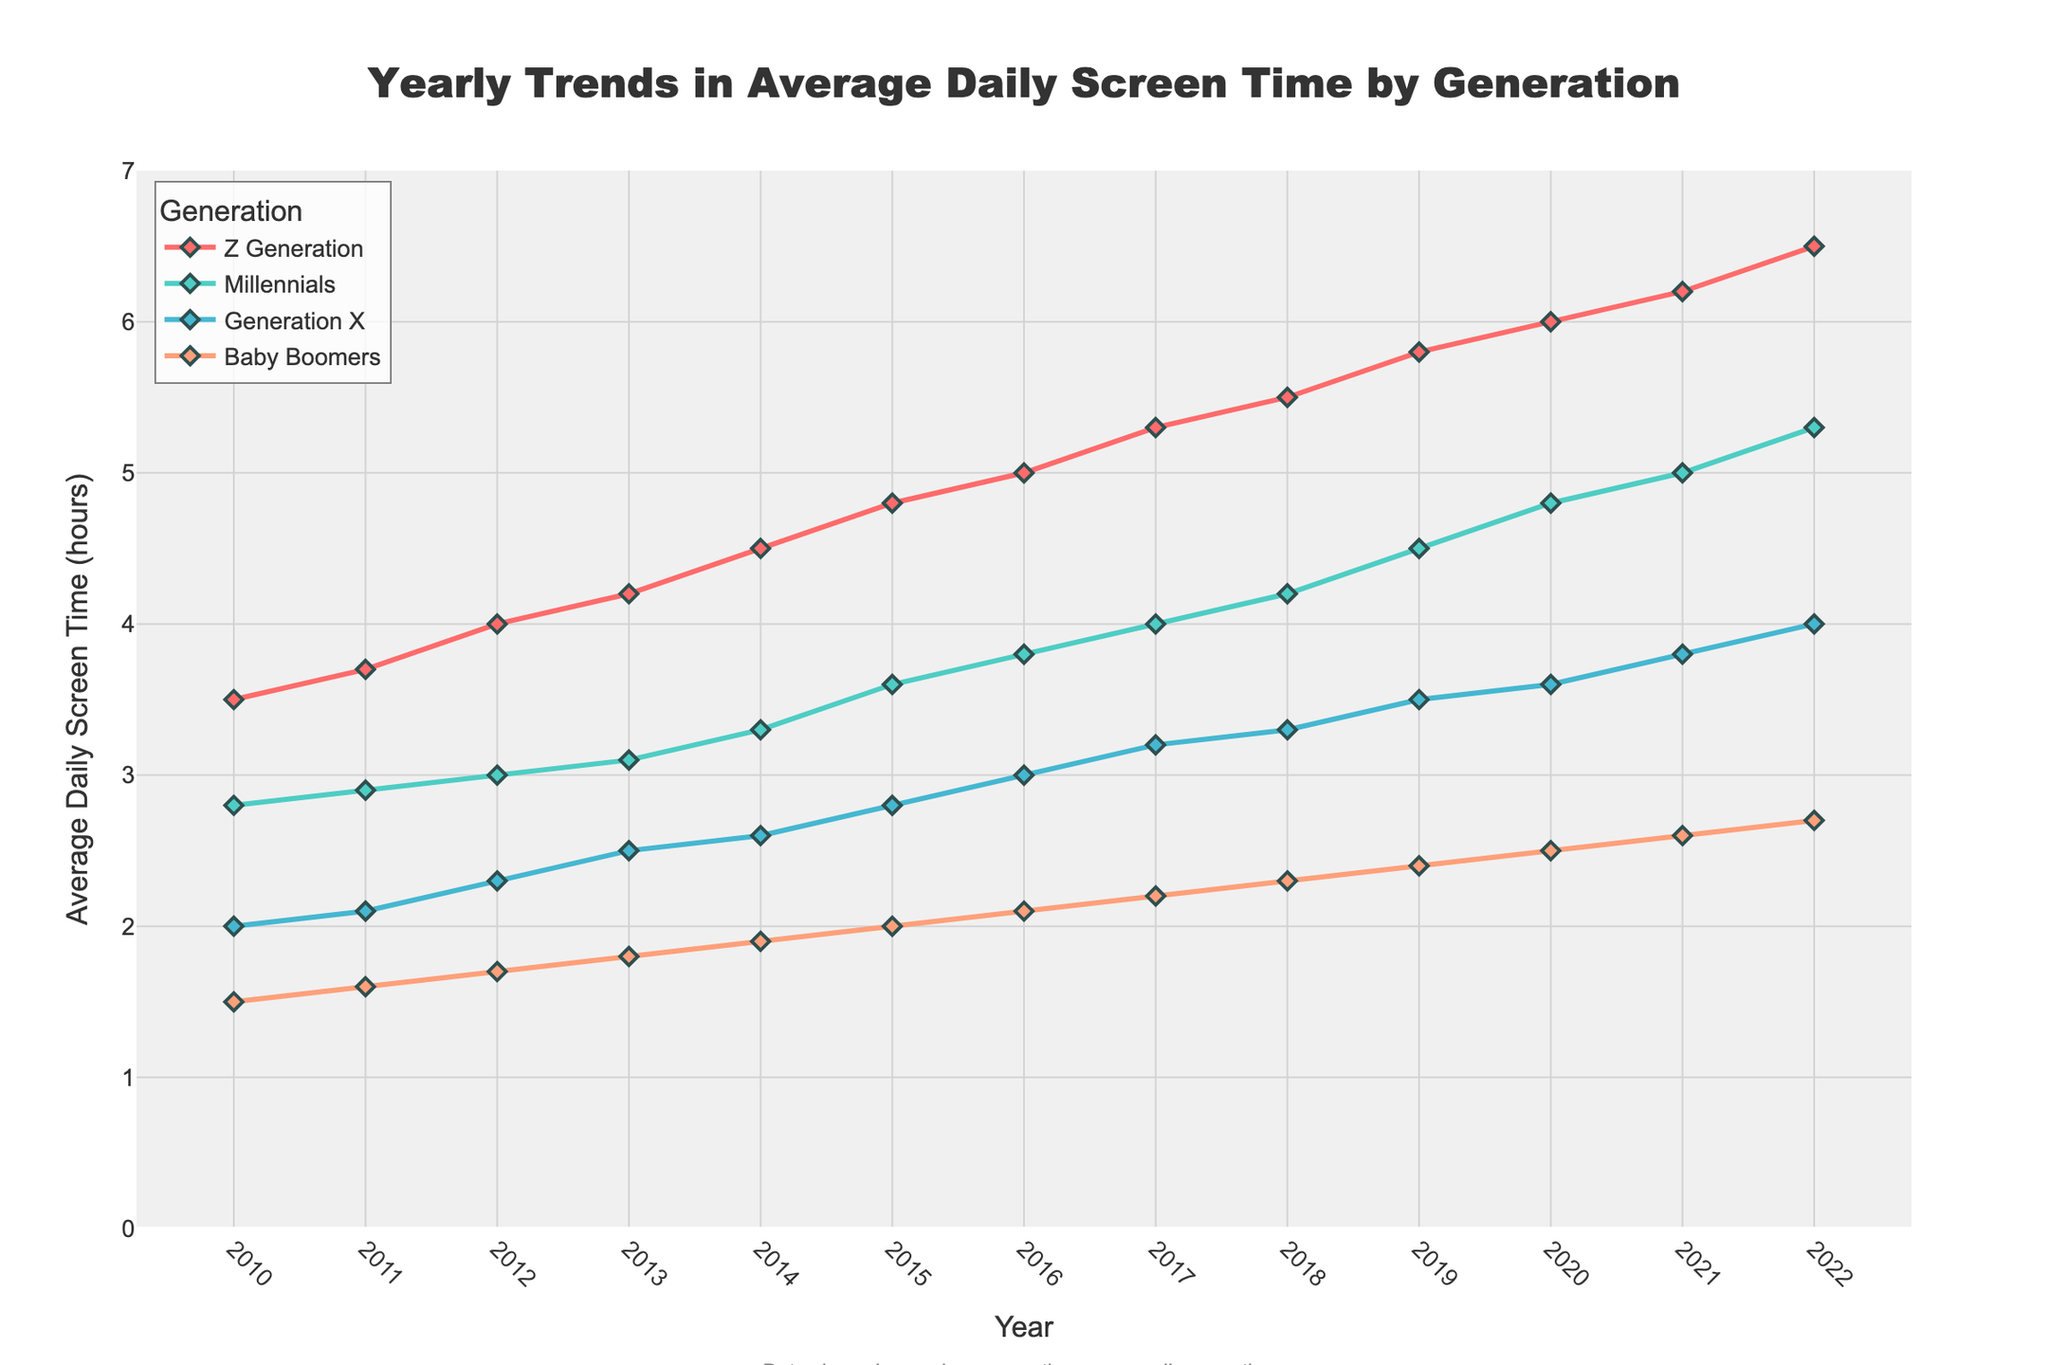what is the title of the plot? The title is prominently displayed at the top center of the plot, indicating the main topic
Answer: Yearly Trends in Average Daily Screen Time by Generation What is the range of years displayed on the x-axis? The x-axis shows the progression of time, helping us understand the timeline of the data
Answer: 2010 to 2022 Which generation had the highest average daily screen time in 2022? By examining the figure, the line representing the highest value in 2022 can be identified
Answer: Z Generation What was the average daily screen time for Baby Boomers in 2014? Locate the data point where the Baby Boomers' line intersects 2014 on the x-axis and read the corresponding y-value
Answer: 1.9 hours By how much did the average daily screen time for Millennials increase from 2010 to 2020? Calculate the difference between the screen time value for Millennials in 2020 and 2010
Answer: 4.8 - 2.8 = 2 hours Which generation saw the smallest increase in average daily screen time from 2010 to 2022? Compare the total increases for each generation by subtracting their 2010 values from 2022 values
Answer: Baby Boomers On which year did Generation X surpass 3 hours of daily screen time? Identify the first year where Generation X's line crosses the 3-hour mark on the y-axis
Answer: 2016 How does the trend in average daily screen time for Generation X compare to Millennials from 2010 to 2022? Assess the slopes and shapes of the lines representing Generation X and Millennials over the years
Answer: Both saw a steady increase, but Millennials had a higher overall increase Describe the trend in screen time for Z Generation from 2010 to 2022. Follow the Z Generation line from 2010 through 2022 to describe its pattern
Answer: Consistent increase from 3.5 hours in 2010 to 6.5 hours in 2022 Around which year did the Baby Boomers' average daily screen time exceed 2 hours? Locate the point when the Baby Boomers' line crosses the 2-hour mark on the y-axis
Answer: Around 2015 